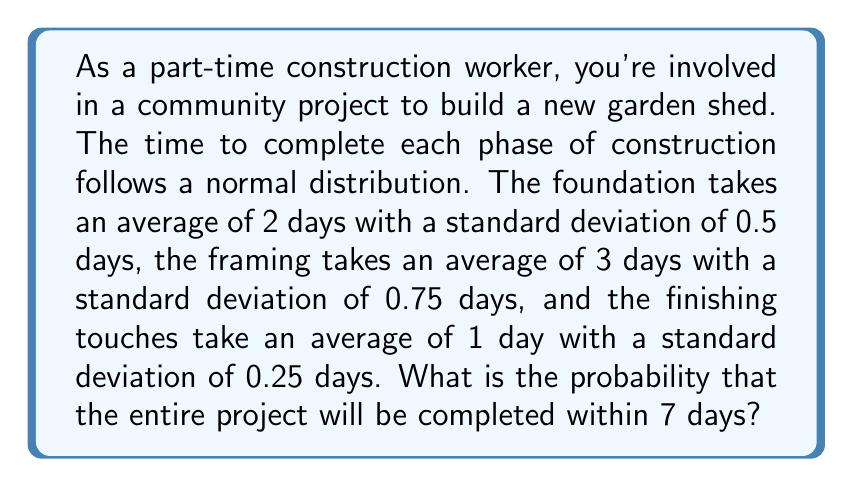Provide a solution to this math problem. Let's approach this step-by-step:

1) First, we need to find the total mean and standard deviation for the project:

   Mean: $\mu = 2 + 3 + 1 = 6$ days
   
   Variance: $\sigma^2 = 0.5^2 + 0.75^2 + 0.25^2 = 0.8125$
   
   Standard deviation: $\sigma = \sqrt{0.8125} \approx 0.9014$ days

2) We want to find $P(X \leq 7)$ where $X$ is the total time to complete the project.

3) We can standardize this to a Z-score:

   $Z = \frac{X - \mu}{\sigma} = \frac{7 - 6}{0.9014} \approx 1.11$

4) Now we need to find $P(Z \leq 1.11)$ using a standard normal distribution table or calculator.

5) Using a calculator or standard normal table, we find:

   $P(Z \leq 1.11) \approx 0.8665$

Therefore, the probability of completing the project within 7 days is approximately 0.8665 or 86.65%.
Answer: 0.8665 